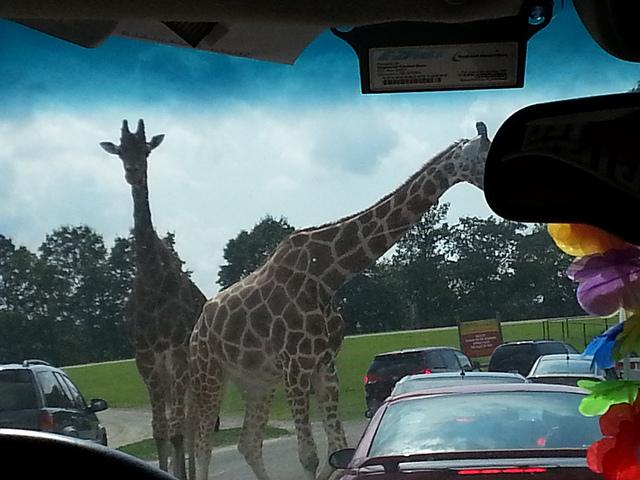How many giraffes are there?
Be succinct. 2. Are the giraffes on the road?
Give a very brief answer. Yes. What color are the giraffes?
Be succinct. Brown and yellow. 